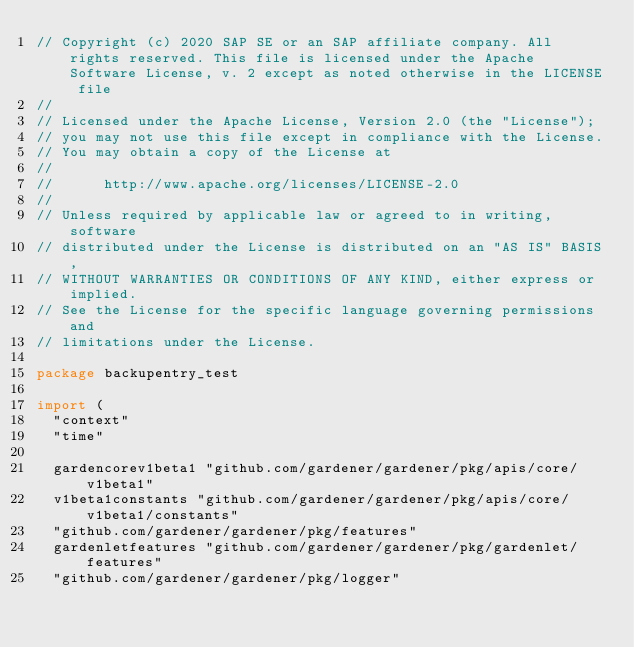Convert code to text. <code><loc_0><loc_0><loc_500><loc_500><_Go_>// Copyright (c) 2020 SAP SE or an SAP affiliate company. All rights reserved. This file is licensed under the Apache Software License, v. 2 except as noted otherwise in the LICENSE file
//
// Licensed under the Apache License, Version 2.0 (the "License");
// you may not use this file except in compliance with the License.
// You may obtain a copy of the License at
//
//      http://www.apache.org/licenses/LICENSE-2.0
//
// Unless required by applicable law or agreed to in writing, software
// distributed under the License is distributed on an "AS IS" BASIS,
// WITHOUT WARRANTIES OR CONDITIONS OF ANY KIND, either express or implied.
// See the License for the specific language governing permissions and
// limitations under the License.

package backupentry_test

import (
	"context"
	"time"

	gardencorev1beta1 "github.com/gardener/gardener/pkg/apis/core/v1beta1"
	v1beta1constants "github.com/gardener/gardener/pkg/apis/core/v1beta1/constants"
	"github.com/gardener/gardener/pkg/features"
	gardenletfeatures "github.com/gardener/gardener/pkg/gardenlet/features"
	"github.com/gardener/gardener/pkg/logger"</code> 